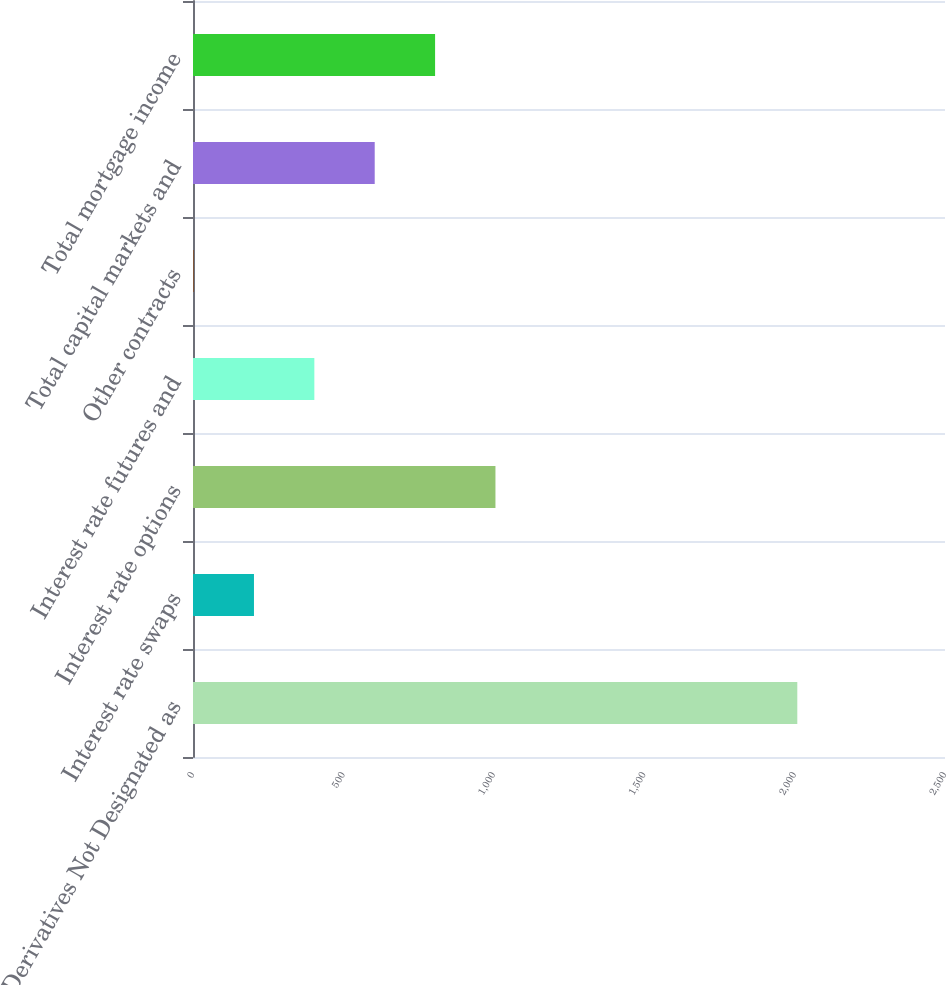Convert chart. <chart><loc_0><loc_0><loc_500><loc_500><bar_chart><fcel>Derivatives Not Designated as<fcel>Interest rate swaps<fcel>Interest rate options<fcel>Interest rate futures and<fcel>Other contracts<fcel>Total capital markets and<fcel>Total mortgage income<nl><fcel>2009<fcel>202.7<fcel>1005.5<fcel>403.4<fcel>2<fcel>604.1<fcel>804.8<nl></chart> 